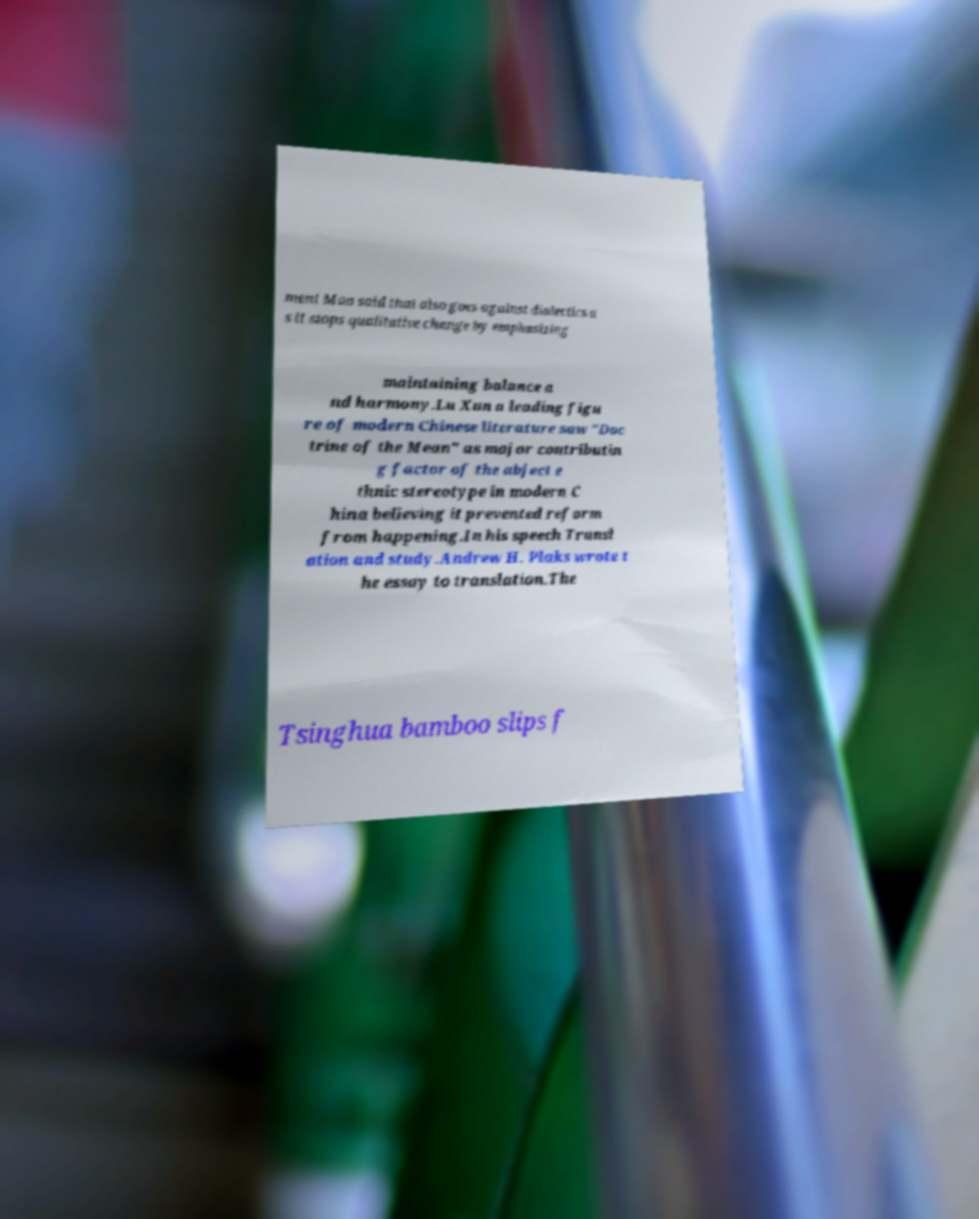Could you extract and type out the text from this image? ment Mao said that also goes against dialectics a s it stops qualitative change by emphasizing maintaining balance a nd harmony.Lu Xun a leading figu re of modern Chinese literature saw "Doc trine of the Mean" as major contributin g factor of the abject e thnic stereotype in modern C hina believing it prevented reform from happening.In his speech Transl ation and study.Andrew H. Plaks wrote t he essay to translation.The Tsinghua bamboo slips f 